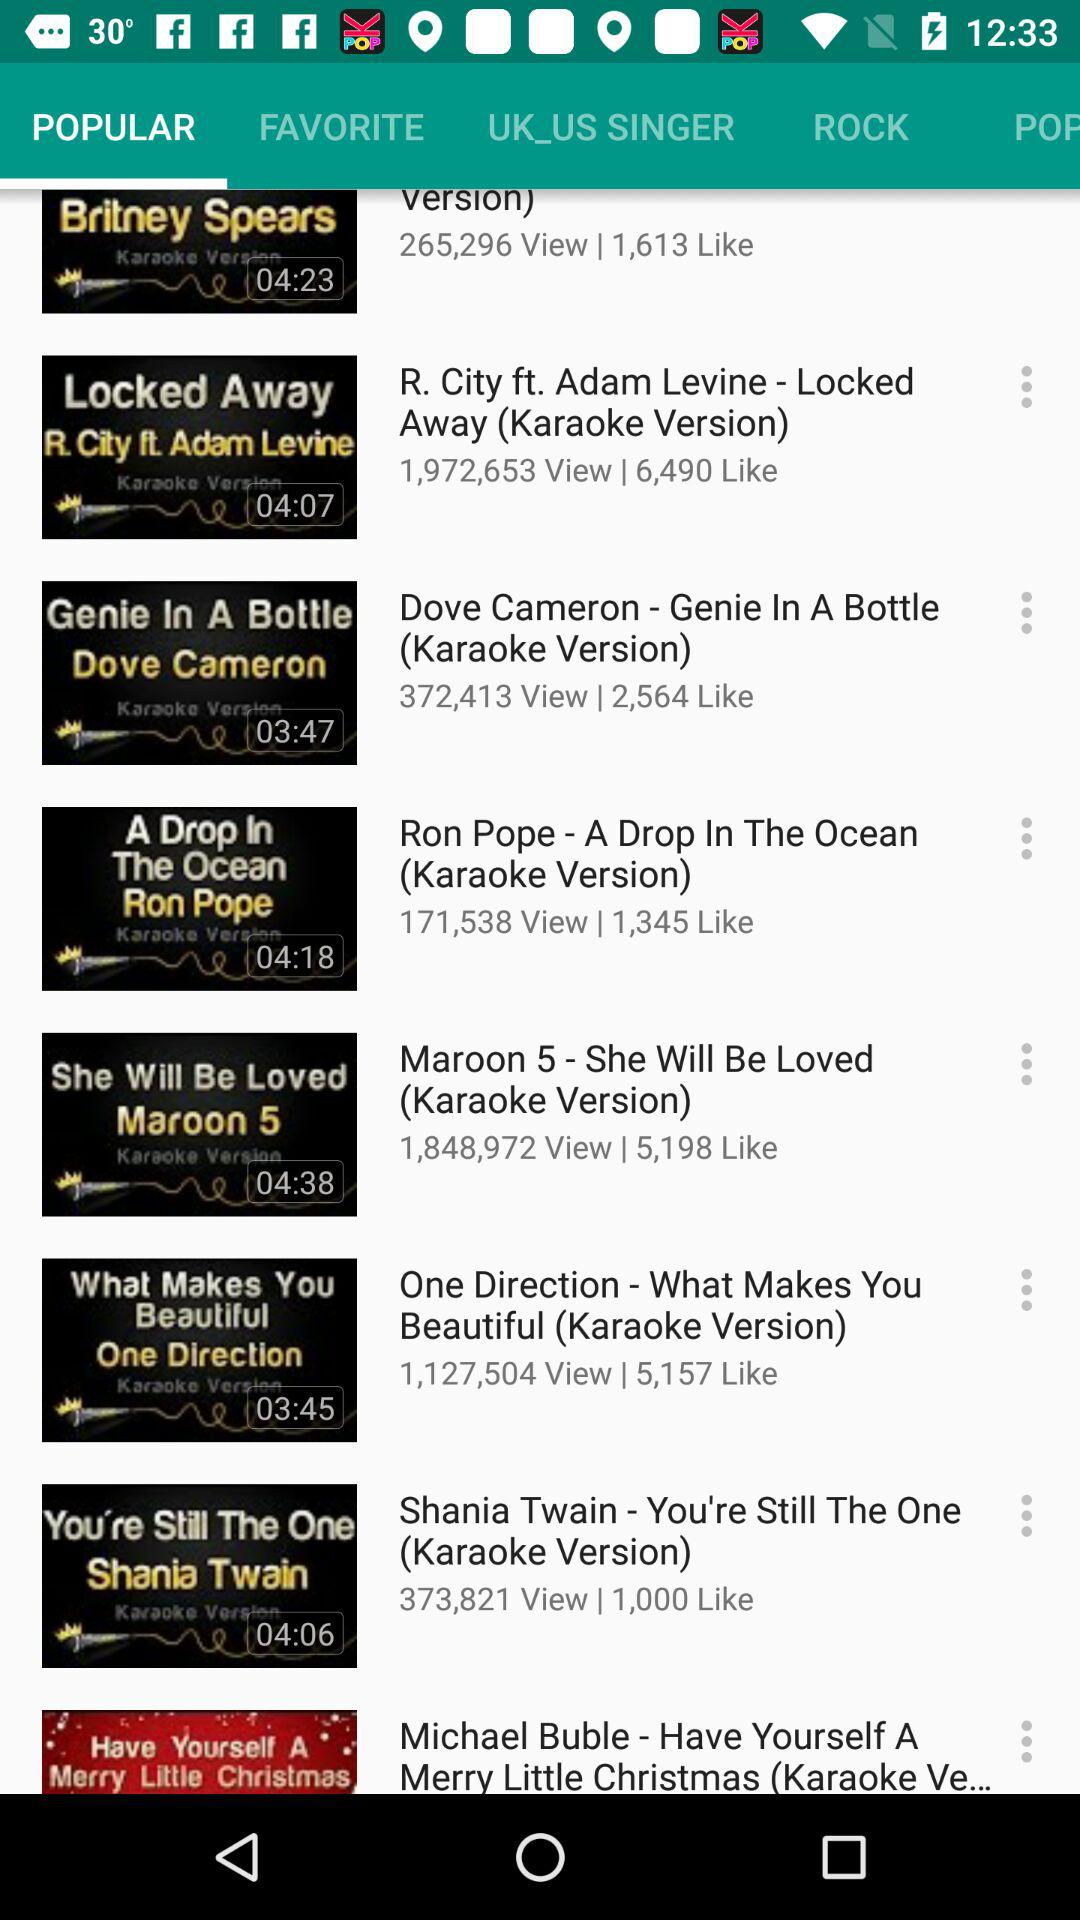What tab is selected? The selected tab is "POPULAR". 